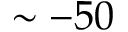Convert formula to latex. <formula><loc_0><loc_0><loc_500><loc_500>\sim - 5 0</formula> 